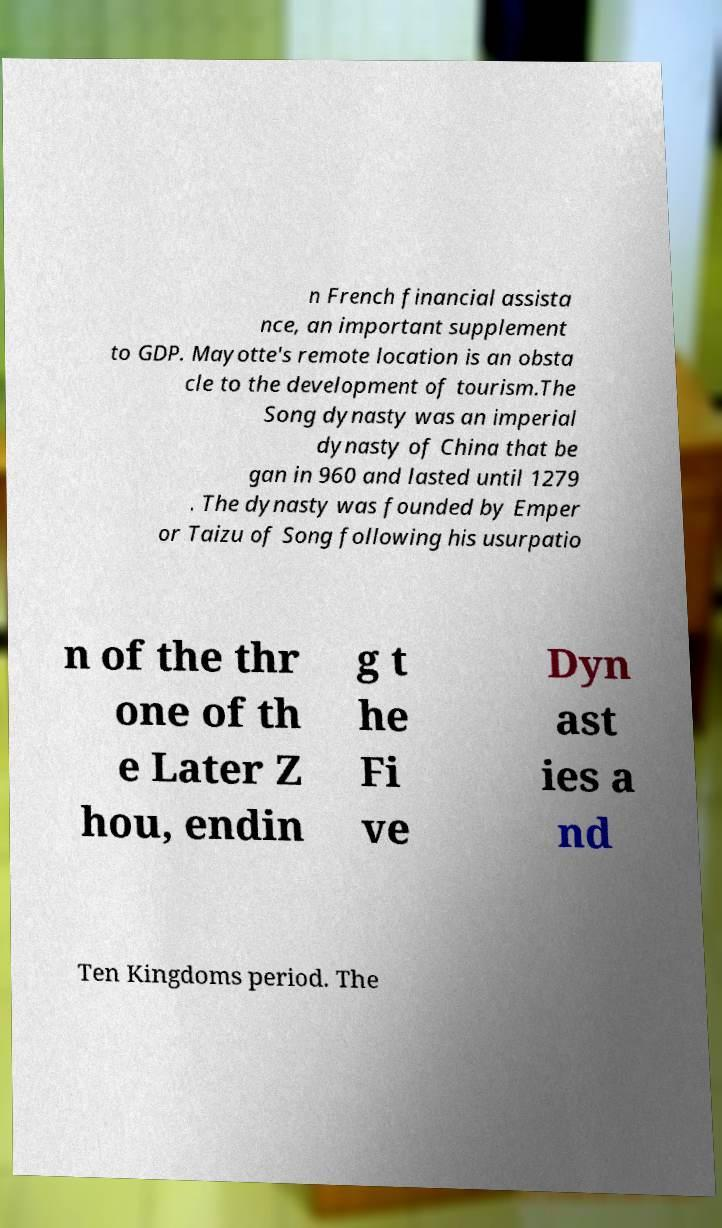Could you extract and type out the text from this image? n French financial assista nce, an important supplement to GDP. Mayotte's remote location is an obsta cle to the development of tourism.The Song dynasty was an imperial dynasty of China that be gan in 960 and lasted until 1279 . The dynasty was founded by Emper or Taizu of Song following his usurpatio n of the thr one of th e Later Z hou, endin g t he Fi ve Dyn ast ies a nd Ten Kingdoms period. The 